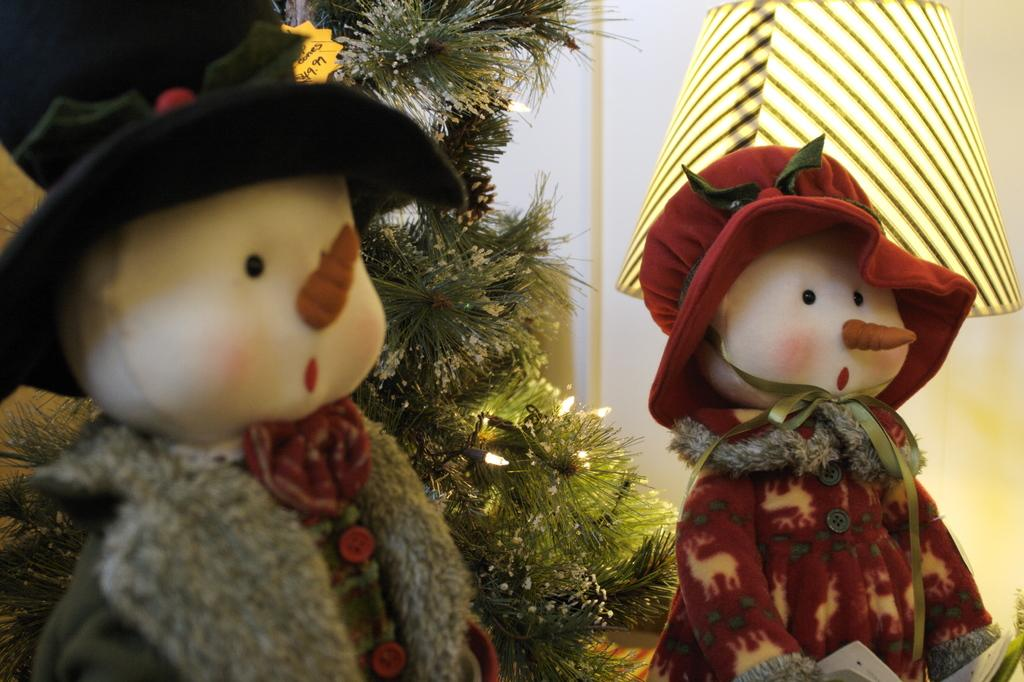What type of objects are wearing caps in the image? There are toys wearing caps in the image. What can be seen on the right side of the image? There is a lamp on the right side of the image. What is the main feature in the middle of the image? There is a Christmas tree in the middle of the image. How is the Christmas tree decorated? The Christmas tree has lights decorated on it. What is visible in the background of the image? There is a wall in the background of the image. Can you tell me how many goldfish are swimming around the toys in the image? There are no goldfish present in the image; it features toys wearing caps and a Christmas tree. What type of metal is used to make the lock on the Christmas tree in the image? There is no lock present on the Christmas tree in the image. 